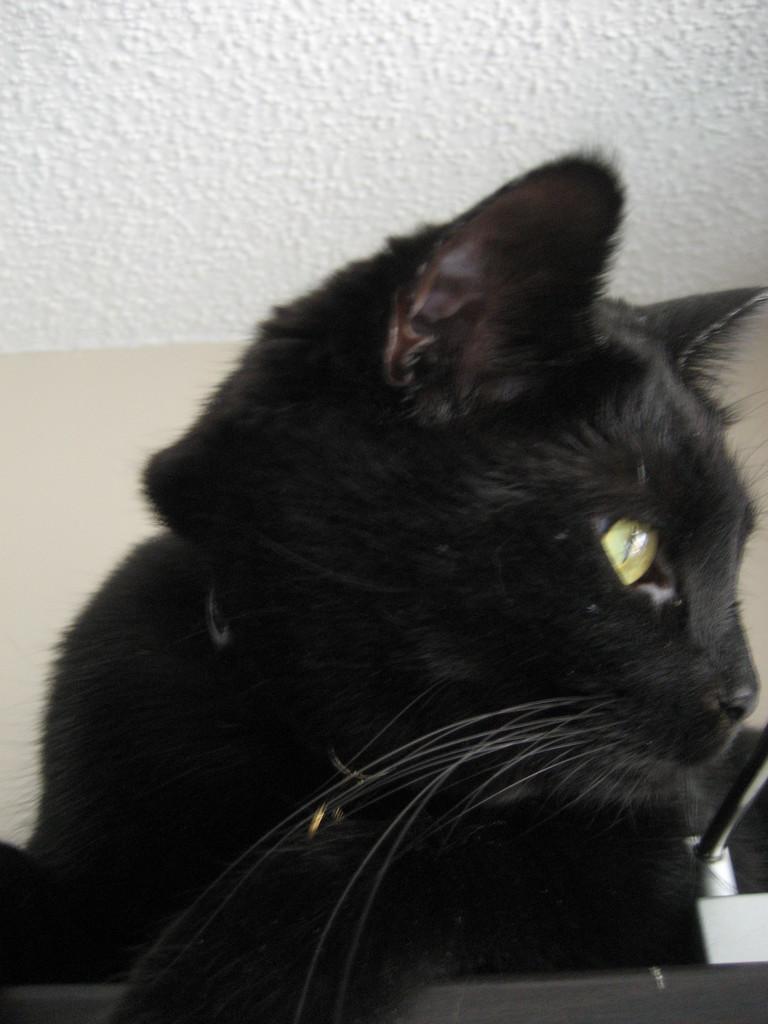Please provide a concise description of this image. It's a black a color cat and this is the wall. 